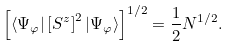<formula> <loc_0><loc_0><loc_500><loc_500>\left [ \langle \Psi _ { \varphi } | \left [ S ^ { z } \right ] ^ { 2 } | \Psi _ { \varphi } \rangle \right ] ^ { 1 / 2 } = \frac { 1 } { 2 } N ^ { 1 / 2 } .</formula> 